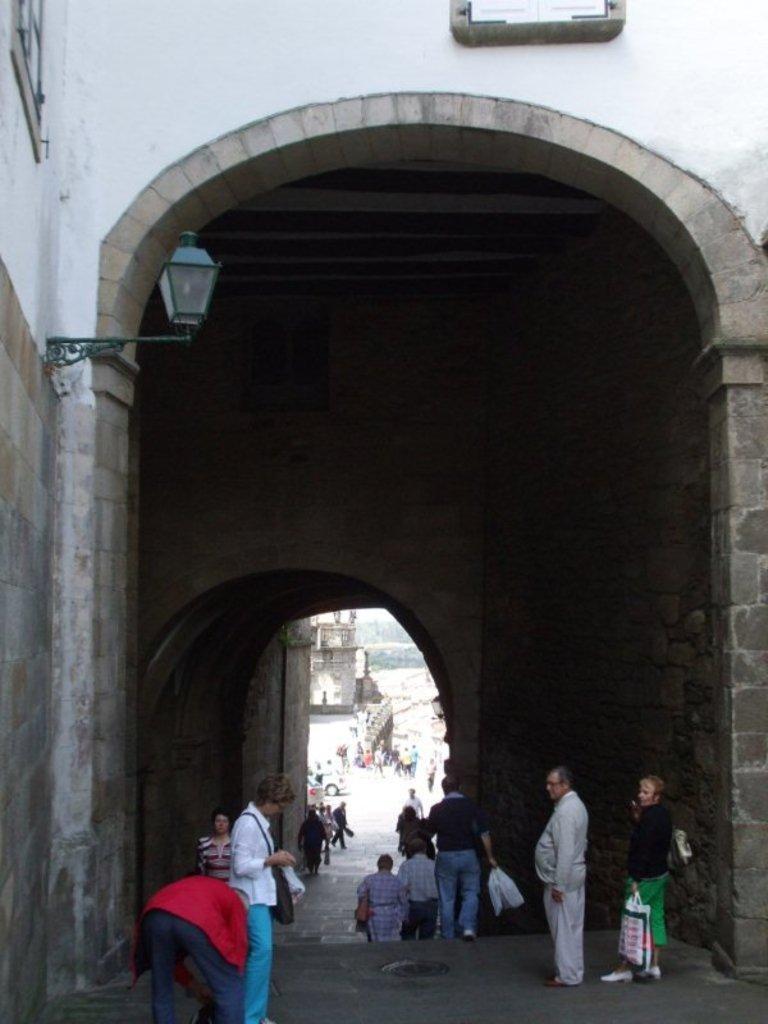Can you describe this image briefly? In this image there is a tunnel under which there are so many people. On the left side there is a lamp to the wall. 